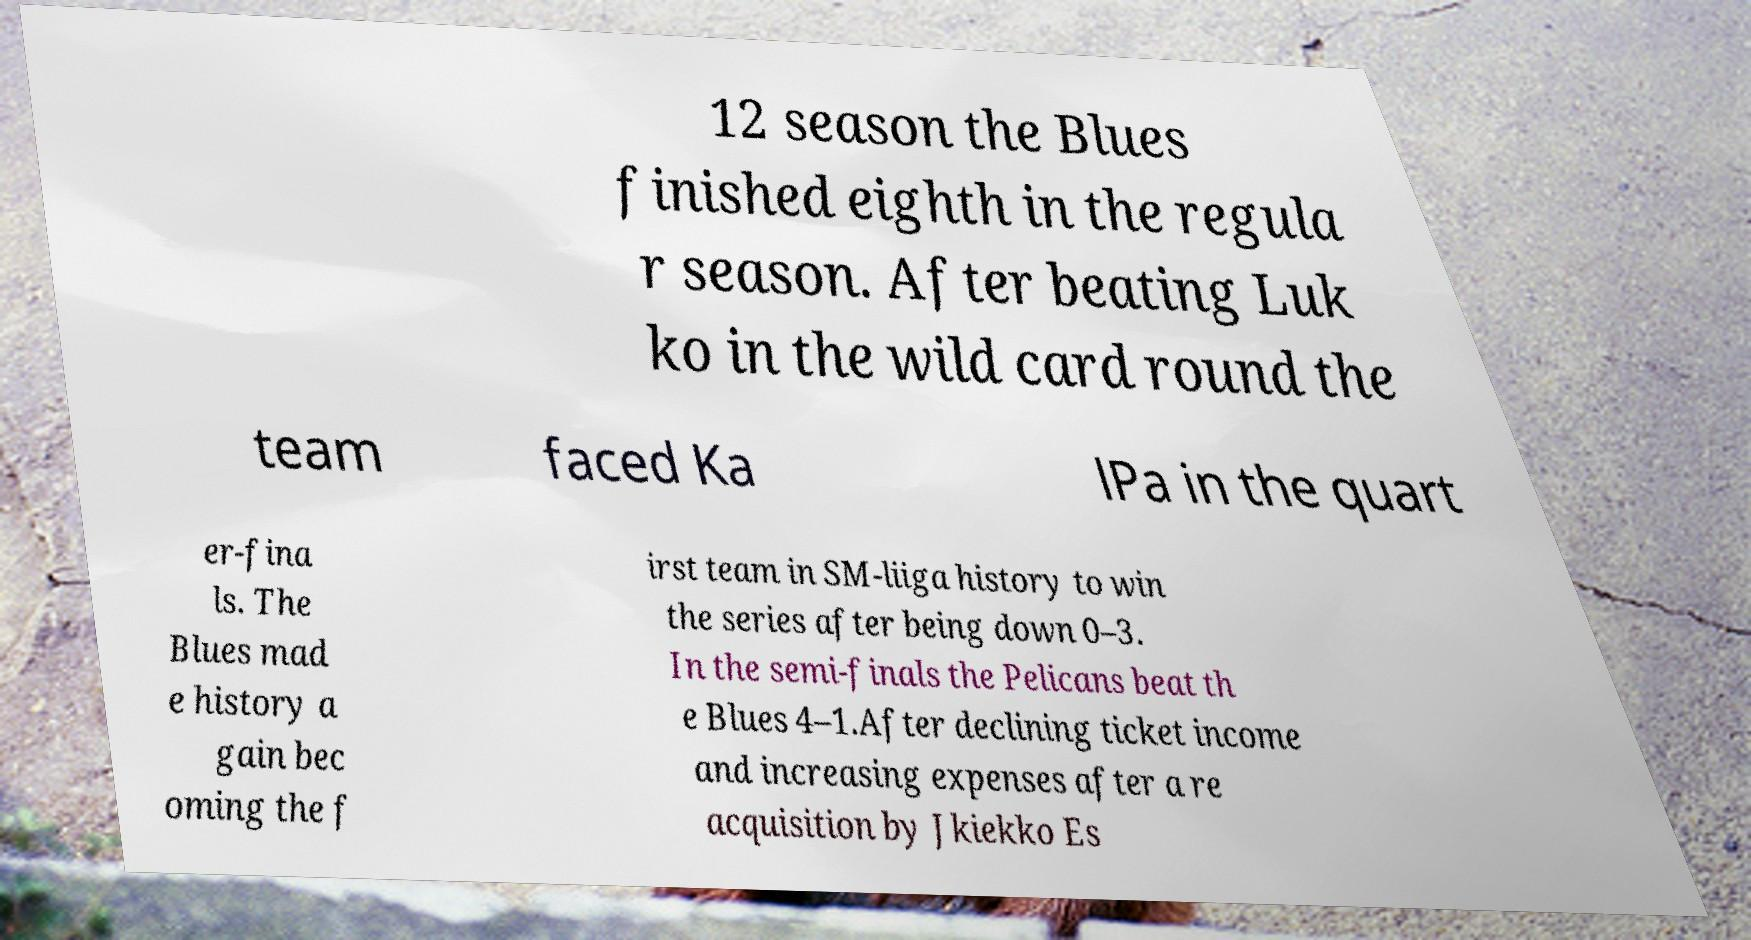I need the written content from this picture converted into text. Can you do that? 12 season the Blues finished eighth in the regula r season. After beating Luk ko in the wild card round the team faced Ka lPa in the quart er-fina ls. The Blues mad e history a gain bec oming the f irst team in SM-liiga history to win the series after being down 0–3. In the semi-finals the Pelicans beat th e Blues 4–1.After declining ticket income and increasing expenses after a re acquisition by Jkiekko Es 